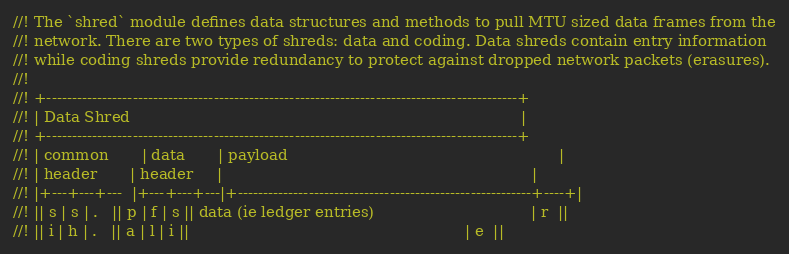<code> <loc_0><loc_0><loc_500><loc_500><_Rust_>//! The `shred` module defines data structures and methods to pull MTU sized data frames from the
//! network. There are two types of shreds: data and coding. Data shreds contain entry information
//! while coding shreds provide redundancy to protect against dropped network packets (erasures).
//!
//! +---------------------------------------------------------------------------------------------+
//! | Data Shred                                                                                  |
//! +---------------------------------------------------------------------------------------------+
//! | common       | data       | payload                                                         |
//! | header       | header     |                                                                 |
//! |+---+---+---  |+---+---+---|+----------------------------------------------------------+----+|
//! || s | s | .   || p | f | s || data (ie ledger entries)                                 | r  ||
//! || i | h | .   || a | l | i ||                                                          | e  ||</code> 